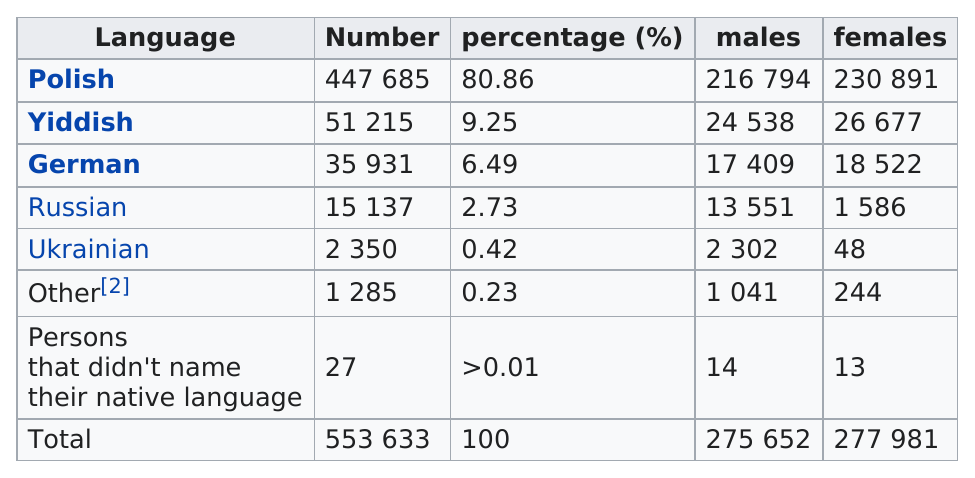Draw attention to some important aspects in this diagram. Ukrainian is the least spoken language. Out of the 14 males who responded, 14 did not have a native language. Four languages have names that are derived from countries. There are approximately 35,931 male and female German speakers. In the 1897 imperial census of the Plock Governorate, only 0.42% of people spoke Ukrainian, making it the least spoken language in the region. 